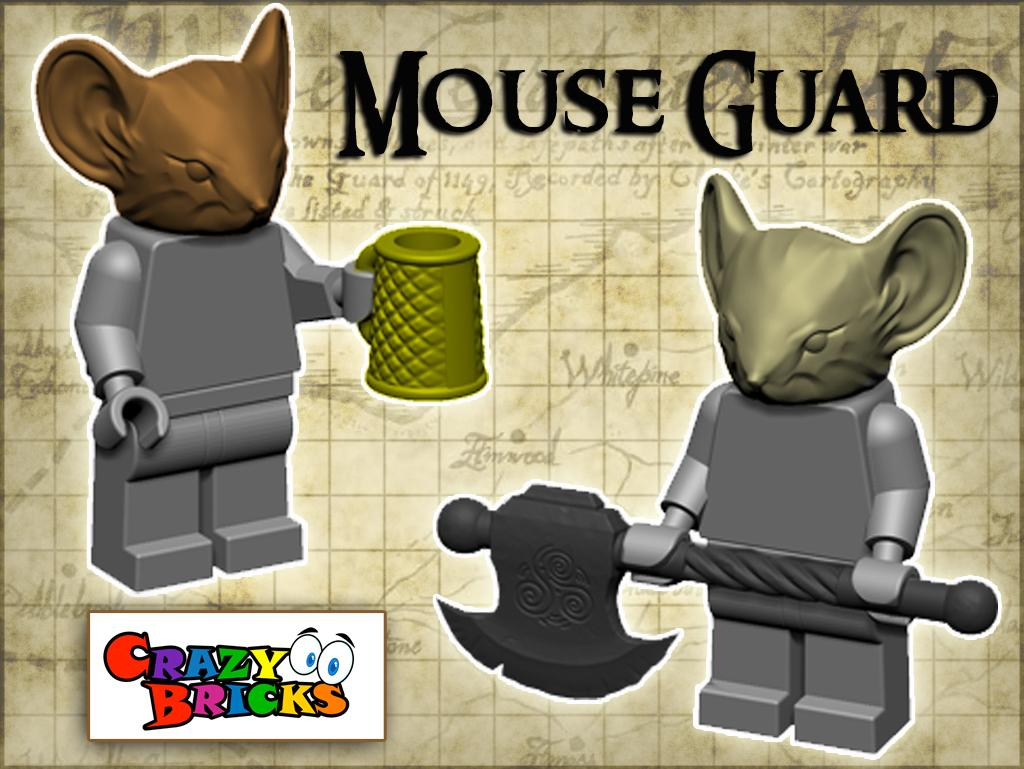What type of character is depicted in the animated images? There are animated images of a mouse in the picture. What is the mouse holding in its hands? The mouse is holding a cup and a weapon. Are there any written words in the image? Yes, there are words written in the image. What type of humor can be seen in the image? There is no specific humor depicted in the image; it features an animated mouse holding a cup and a weapon. What type of grain is visible in the image? There is no grain present in the image. 